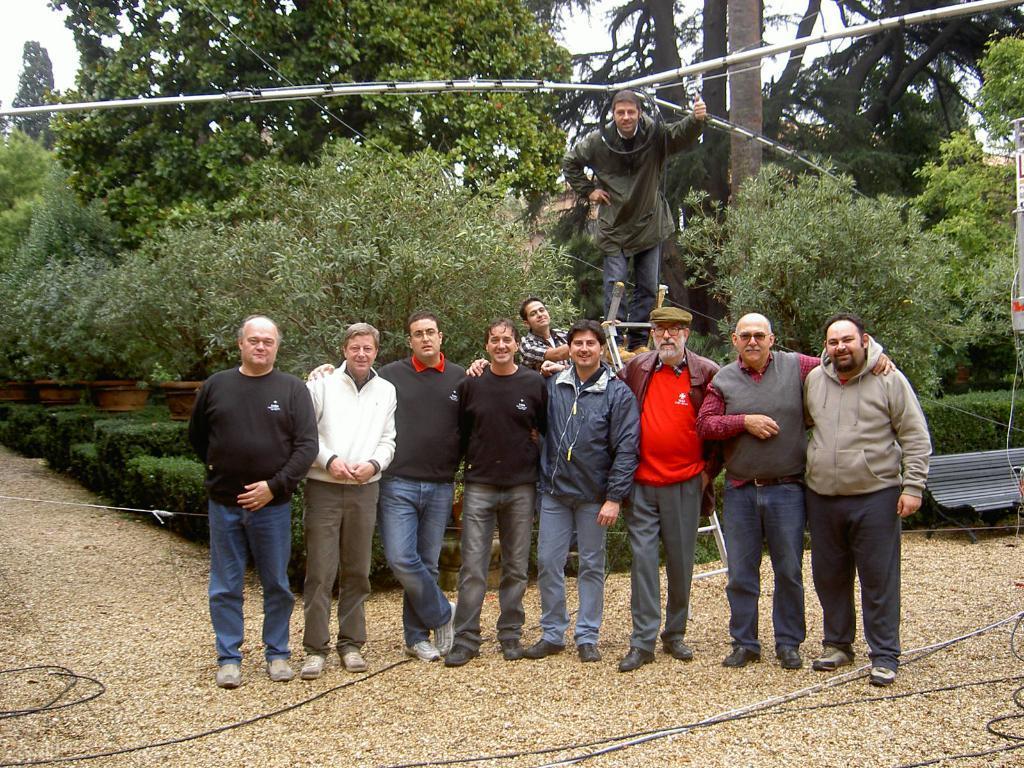In one or two sentences, can you explain what this image depicts? In the image we can see there are trees in a garden and there are men standing accordingly. All the men are wearing jackets and shoes. On the ground there are wires and a man standing on the ladder and he is showing thumbs up. 